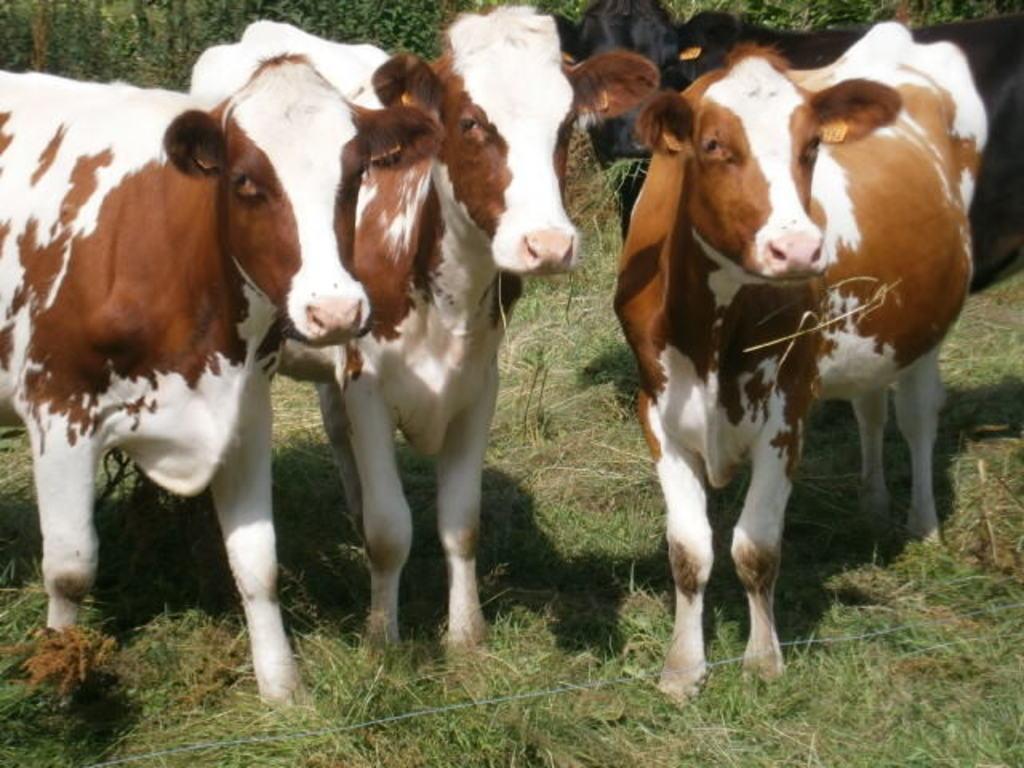In one or two sentences, can you explain what this image depicts? In this image I can see the cows. At the bottom, I can see the grass on the ground. In the background there are many trees. 